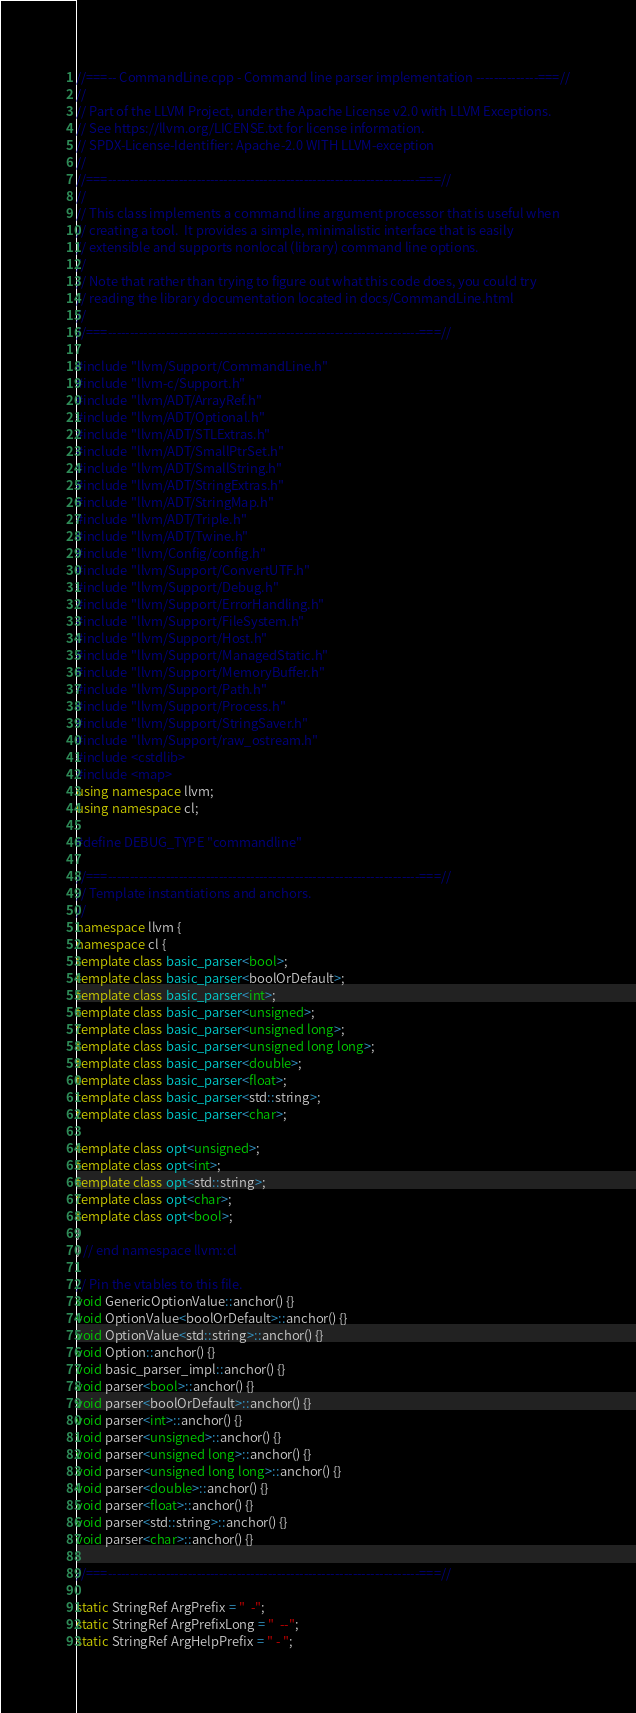Convert code to text. <code><loc_0><loc_0><loc_500><loc_500><_C++_>//===-- CommandLine.cpp - Command line parser implementation --------------===//
//
// Part of the LLVM Project, under the Apache License v2.0 with LLVM Exceptions.
// See https://llvm.org/LICENSE.txt for license information.
// SPDX-License-Identifier: Apache-2.0 WITH LLVM-exception
//
//===----------------------------------------------------------------------===//
//
// This class implements a command line argument processor that is useful when
// creating a tool.  It provides a simple, minimalistic interface that is easily
// extensible and supports nonlocal (library) command line options.
//
// Note that rather than trying to figure out what this code does, you could try
// reading the library documentation located in docs/CommandLine.html
//
//===----------------------------------------------------------------------===//

#include "llvm/Support/CommandLine.h"
#include "llvm-c/Support.h"
#include "llvm/ADT/ArrayRef.h"
#include "llvm/ADT/Optional.h"
#include "llvm/ADT/STLExtras.h"
#include "llvm/ADT/SmallPtrSet.h"
#include "llvm/ADT/SmallString.h"
#include "llvm/ADT/StringExtras.h"
#include "llvm/ADT/StringMap.h"
#include "llvm/ADT/Triple.h"
#include "llvm/ADT/Twine.h"
#include "llvm/Config/config.h"
#include "llvm/Support/ConvertUTF.h"
#include "llvm/Support/Debug.h"
#include "llvm/Support/ErrorHandling.h"
#include "llvm/Support/FileSystem.h"
#include "llvm/Support/Host.h"
#include "llvm/Support/ManagedStatic.h"
#include "llvm/Support/MemoryBuffer.h"
#include "llvm/Support/Path.h"
#include "llvm/Support/Process.h"
#include "llvm/Support/StringSaver.h"
#include "llvm/Support/raw_ostream.h"
#include <cstdlib>
#include <map>
using namespace llvm;
using namespace cl;

#define DEBUG_TYPE "commandline"

//===----------------------------------------------------------------------===//
// Template instantiations and anchors.
//
namespace llvm {
namespace cl {
template class basic_parser<bool>;
template class basic_parser<boolOrDefault>;
template class basic_parser<int>;
template class basic_parser<unsigned>;
template class basic_parser<unsigned long>;
template class basic_parser<unsigned long long>;
template class basic_parser<double>;
template class basic_parser<float>;
template class basic_parser<std::string>;
template class basic_parser<char>;

template class opt<unsigned>;
template class opt<int>;
template class opt<std::string>;
template class opt<char>;
template class opt<bool>;
}
} // end namespace llvm::cl

// Pin the vtables to this file.
void GenericOptionValue::anchor() {}
void OptionValue<boolOrDefault>::anchor() {}
void OptionValue<std::string>::anchor() {}
void Option::anchor() {}
void basic_parser_impl::anchor() {}
void parser<bool>::anchor() {}
void parser<boolOrDefault>::anchor() {}
void parser<int>::anchor() {}
void parser<unsigned>::anchor() {}
void parser<unsigned long>::anchor() {}
void parser<unsigned long long>::anchor() {}
void parser<double>::anchor() {}
void parser<float>::anchor() {}
void parser<std::string>::anchor() {}
void parser<char>::anchor() {}

//===----------------------------------------------------------------------===//

static StringRef ArgPrefix = "  -";
static StringRef ArgPrefixLong = "  --";
static StringRef ArgHelpPrefix = " - ";
</code> 